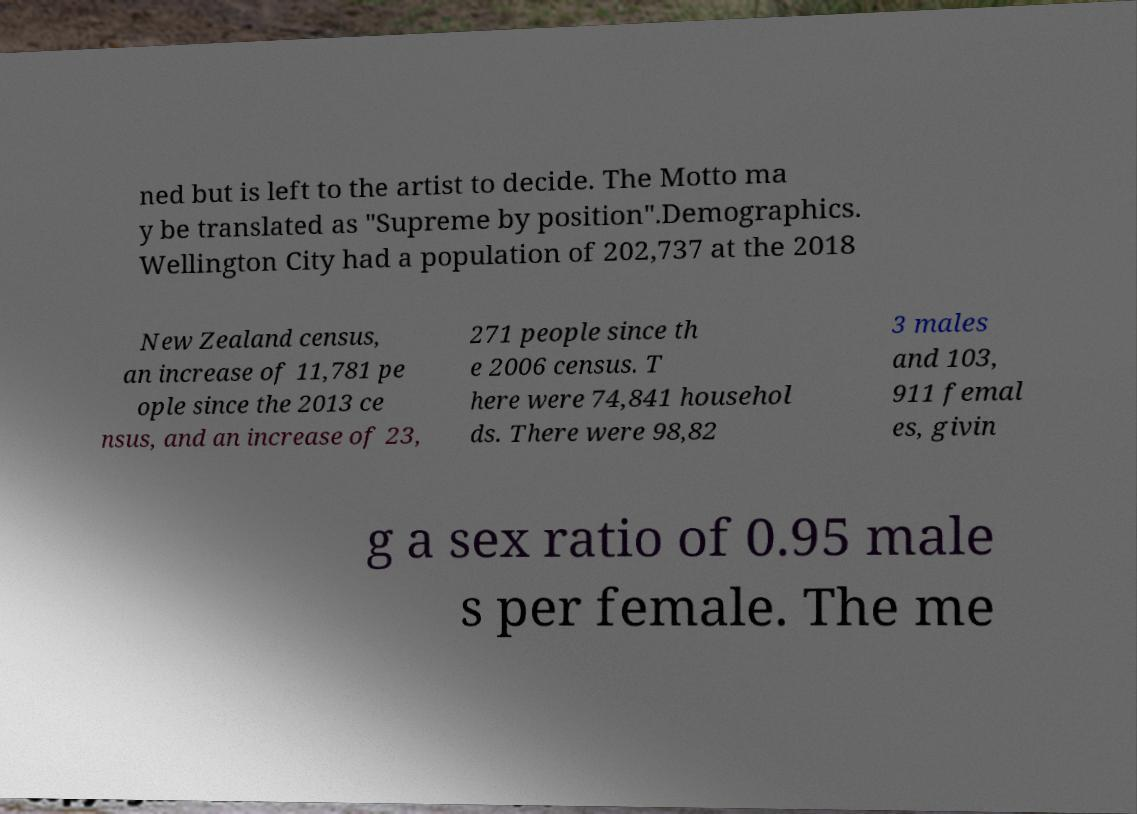Please identify and transcribe the text found in this image. ned but is left to the artist to decide. The Motto ma y be translated as "Supreme by position".Demographics. Wellington City had a population of 202,737 at the 2018 New Zealand census, an increase of 11,781 pe ople since the 2013 ce nsus, and an increase of 23, 271 people since th e 2006 census. T here were 74,841 househol ds. There were 98,82 3 males and 103, 911 femal es, givin g a sex ratio of 0.95 male s per female. The me 